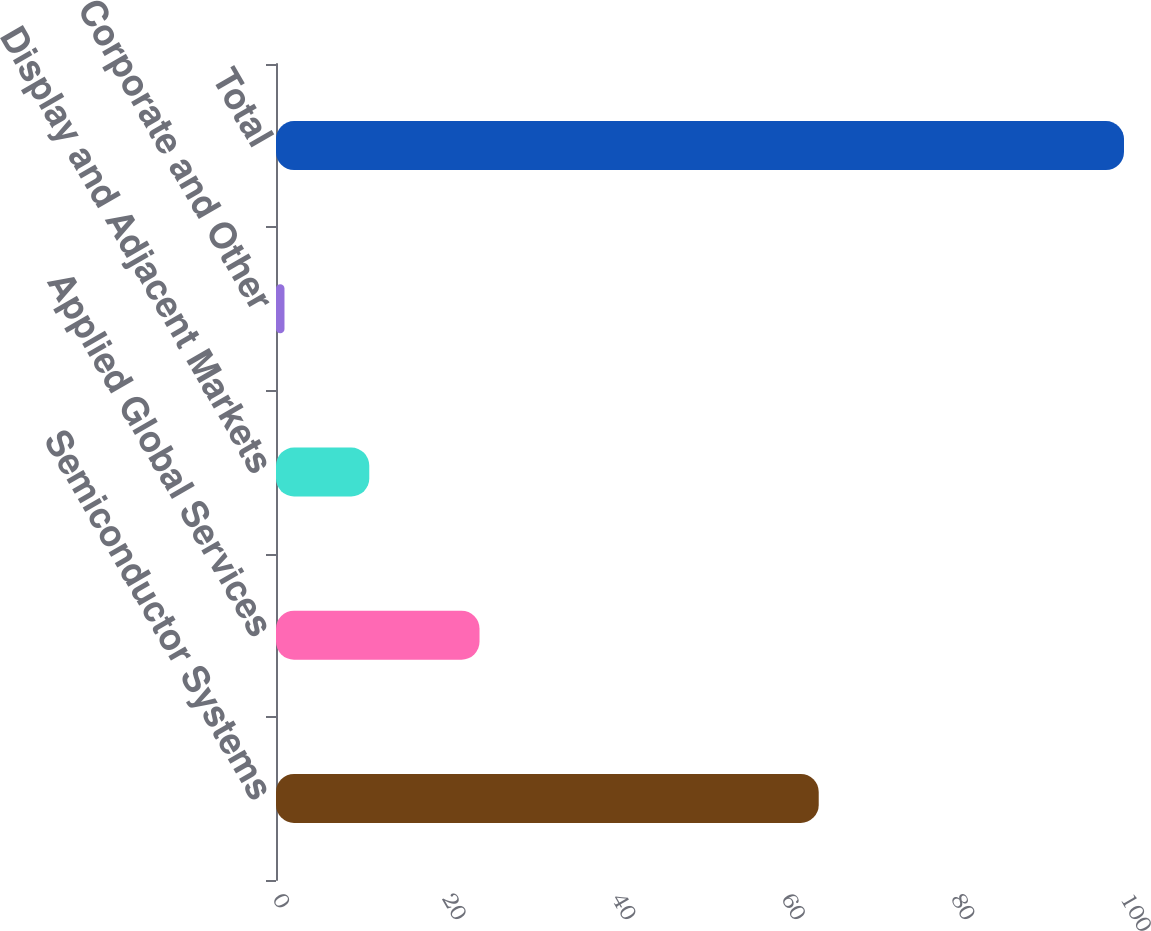Convert chart. <chart><loc_0><loc_0><loc_500><loc_500><bar_chart><fcel>Semiconductor Systems<fcel>Applied Global Services<fcel>Display and Adjacent Markets<fcel>Corporate and Other<fcel>Total<nl><fcel>64<fcel>24<fcel>11<fcel>1<fcel>100<nl></chart> 